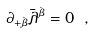<formula> <loc_0><loc_0><loc_500><loc_500>\partial _ { + \dot { \beta } } \bar { \lambda } ^ { \dot { \beta } } = 0 \ ,</formula> 